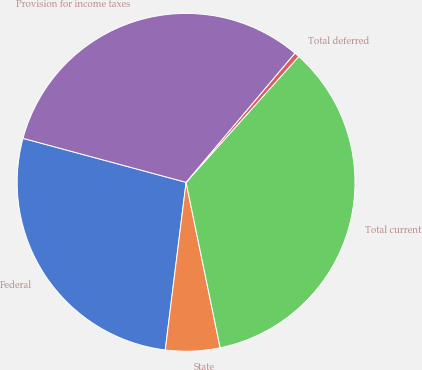Convert chart to OTSL. <chart><loc_0><loc_0><loc_500><loc_500><pie_chart><fcel>Federal<fcel>State<fcel>Total current<fcel>Total deferred<fcel>Provision for income taxes<nl><fcel>27.23%<fcel>5.2%<fcel>35.15%<fcel>0.48%<fcel>31.95%<nl></chart> 